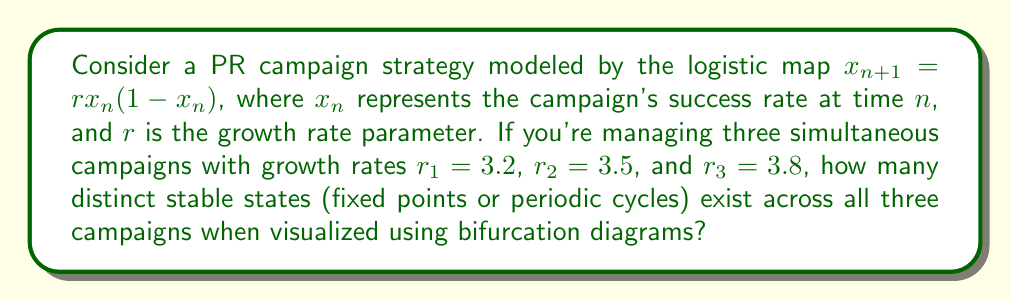Could you help me with this problem? To solve this problem, we need to analyze the behavior of the logistic map for each given growth rate using bifurcation diagrams:

1. For $r_1 = 3.2$:
   The logistic map exhibits a stable 2-cycle.
   $$x_1 \approx 0.799, x_2 \approx 0.513$$

2. For $r_2 = 3.5$:
   The logistic map exhibits a stable 4-cycle.
   $$x_1 \approx 0.875, x_2 \approx 0.383, x_3 \approx 0.827, x_4 \approx 0.501$$

3. For $r_3 = 3.8$:
   The logistic map exhibits chaotic behavior, with infinitely many states within the attractor.

To count the distinct stable states:
- Campaign 1 ($r_1$): 2 states
- Campaign 2 ($r_2$): 4 states
- Campaign 3 ($r_3$): Infinitely many states

Therefore, across all three campaigns, there are infinitely many distinct stable states due to the chaotic behavior of the third campaign.
Answer: Infinitely many 